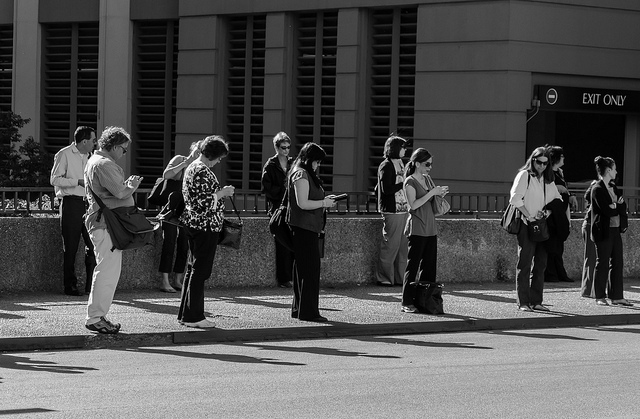<image>What are the men videotaping? I am not sure what the men are videotaping. It could be a ball game, women, people, street or parade. What are the men videotaping? It is unclear what the men are videotaping. It could be a ball game, women, people, or something else. 